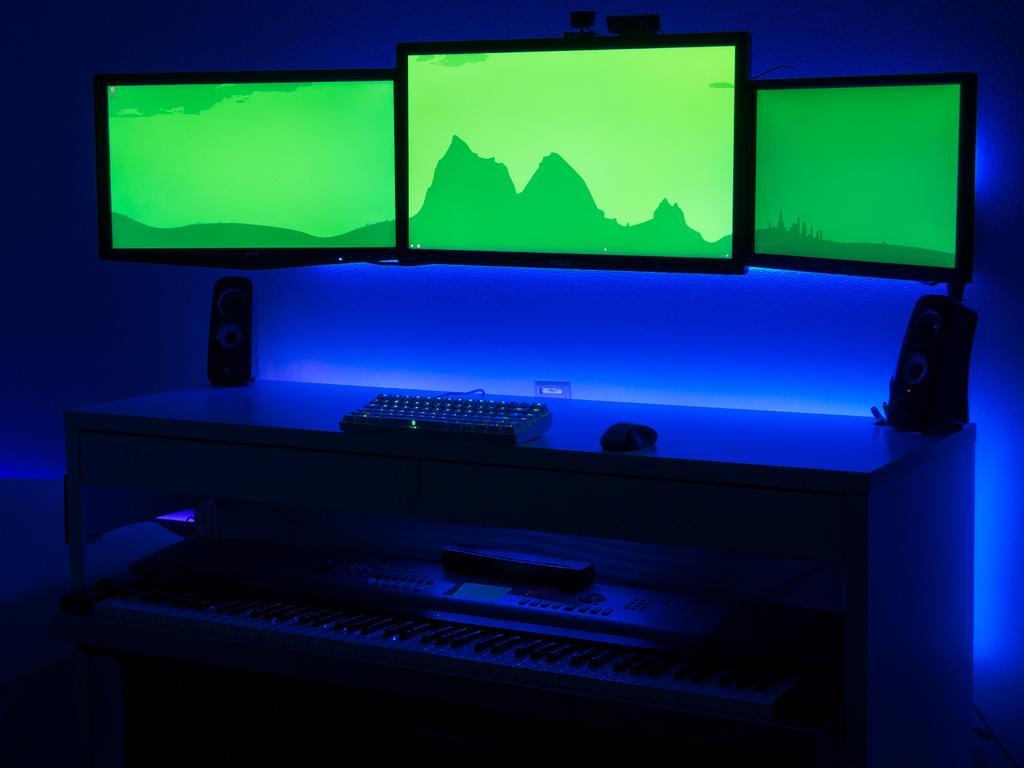In one or two sentences, can you explain what this image depicts? In this picture we can see three monitor screens. These are the woofers. This is a table and on the table we can see a keyboard and a mouse. This is a musical instrument. 